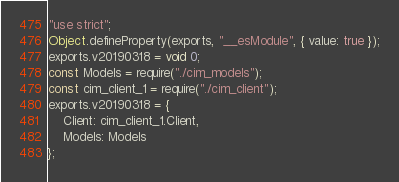<code> <loc_0><loc_0><loc_500><loc_500><_JavaScript_>"use strict";
Object.defineProperty(exports, "__esModule", { value: true });
exports.v20190318 = void 0;
const Models = require("./cim_models");
const cim_client_1 = require("./cim_client");
exports.v20190318 = {
    Client: cim_client_1.Client,
    Models: Models
};
</code> 